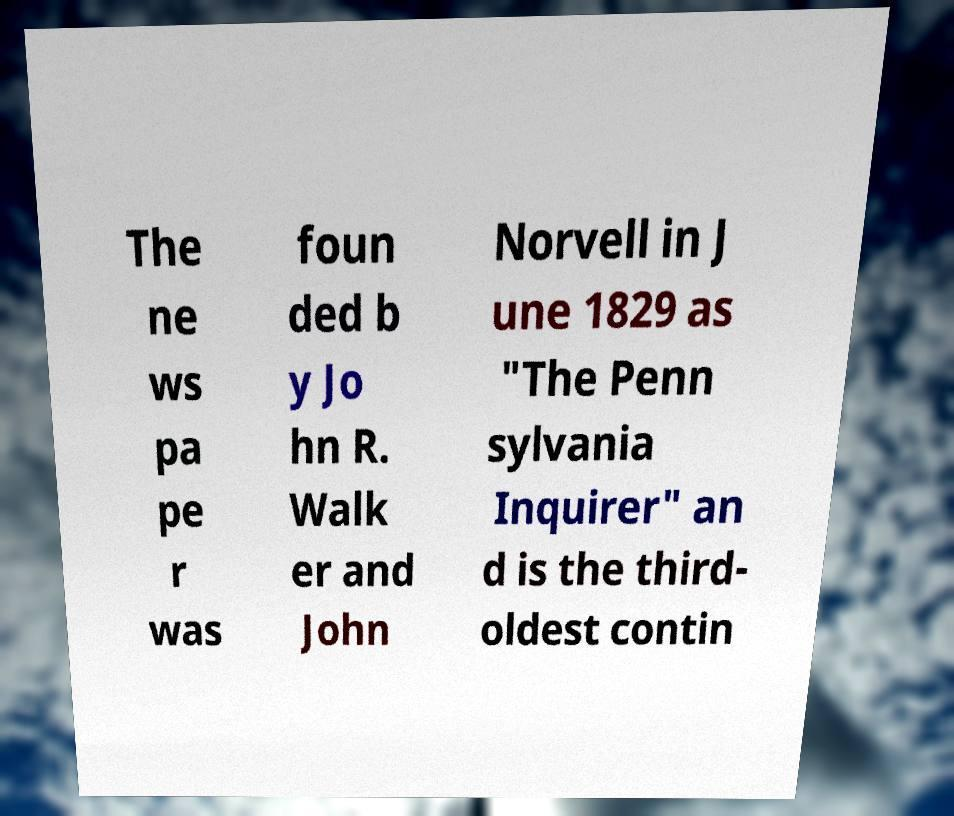Please identify and transcribe the text found in this image. The ne ws pa pe r was foun ded b y Jo hn R. Walk er and John Norvell in J une 1829 as "The Penn sylvania Inquirer" an d is the third- oldest contin 